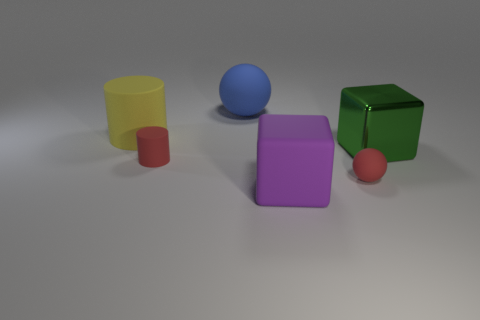Is there anything else that is the same material as the green object?
Your answer should be very brief. No. The object that is the same color as the tiny sphere is what size?
Make the answer very short. Small. Is the color of the small object that is right of the big purple cube the same as the small matte cylinder?
Keep it short and to the point. Yes. Do the yellow cylinder and the purple matte thing have the same size?
Make the answer very short. Yes. What color is the tiny rubber object that is the same shape as the large yellow matte object?
Ensure brevity in your answer.  Red. What number of cylinders are the same color as the small sphere?
Give a very brief answer. 1. Is the number of objects that are on the right side of the tiny red cylinder greater than the number of large purple objects?
Give a very brief answer. Yes. There is a ball that is right of the matte ball behind the red rubber cylinder; what is its color?
Provide a succinct answer. Red. What number of things are things that are in front of the yellow matte cylinder or big yellow things that are to the left of the tiny red cylinder?
Your response must be concise. 5. The big cylinder has what color?
Your response must be concise. Yellow. 